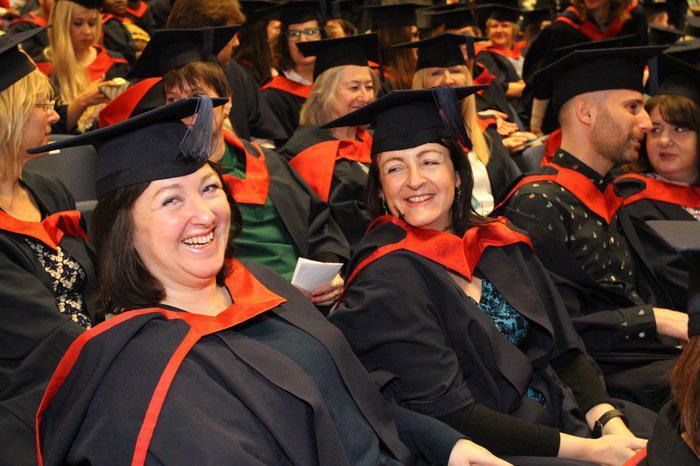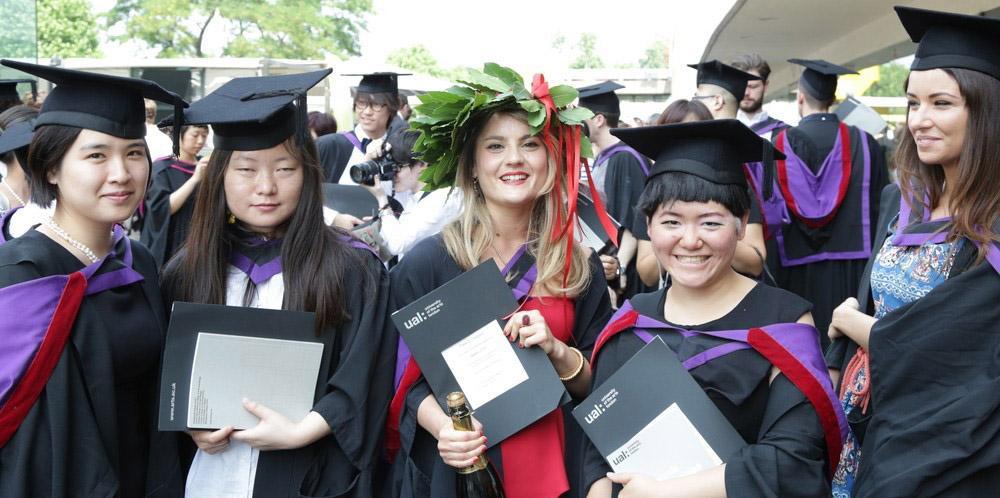The first image is the image on the left, the second image is the image on the right. For the images shown, is this caption "There are four graduates in one of the images." true? Answer yes or no. No. The first image is the image on the left, the second image is the image on the right. Considering the images on both sides, is "One image shows a single row of standing, camera-facing graduates numbering no more than four, and the other image includes at least some standing graduates who are not facing forward." valid? Answer yes or no. No. 